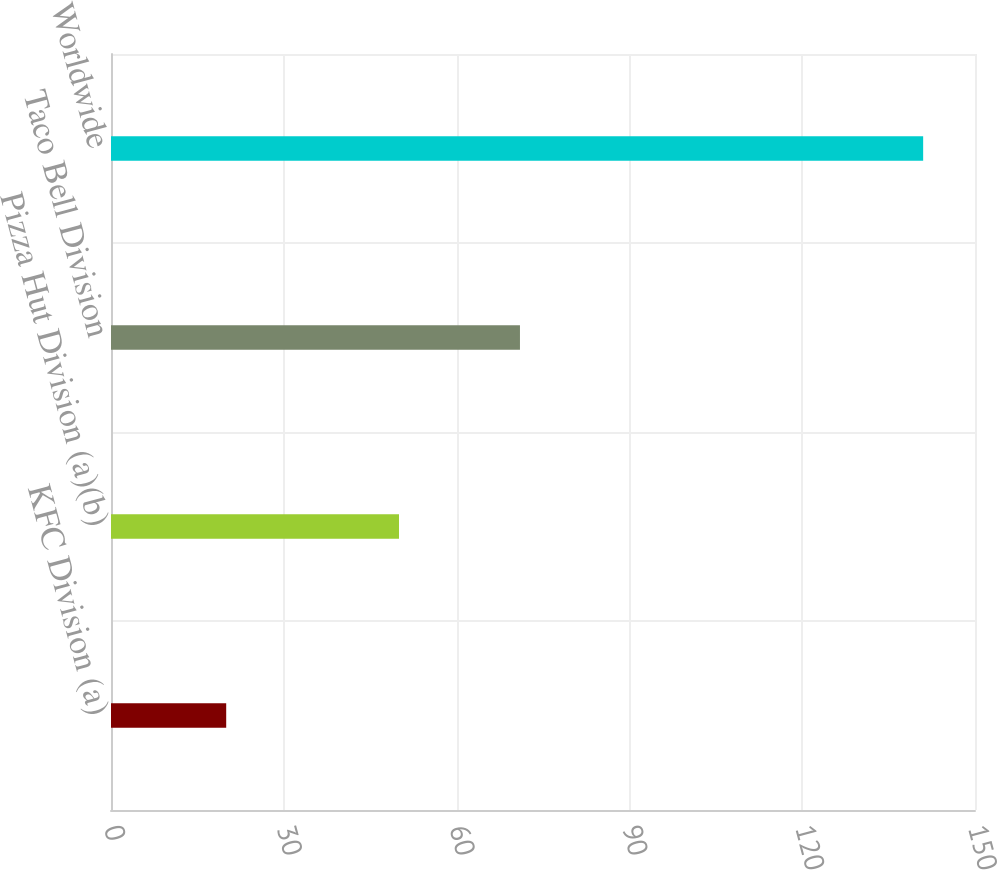Convert chart. <chart><loc_0><loc_0><loc_500><loc_500><bar_chart><fcel>KFC Division (a)<fcel>Pizza Hut Division (a)(b)<fcel>Taco Bell Division<fcel>Worldwide<nl><fcel>20<fcel>50<fcel>71<fcel>141<nl></chart> 